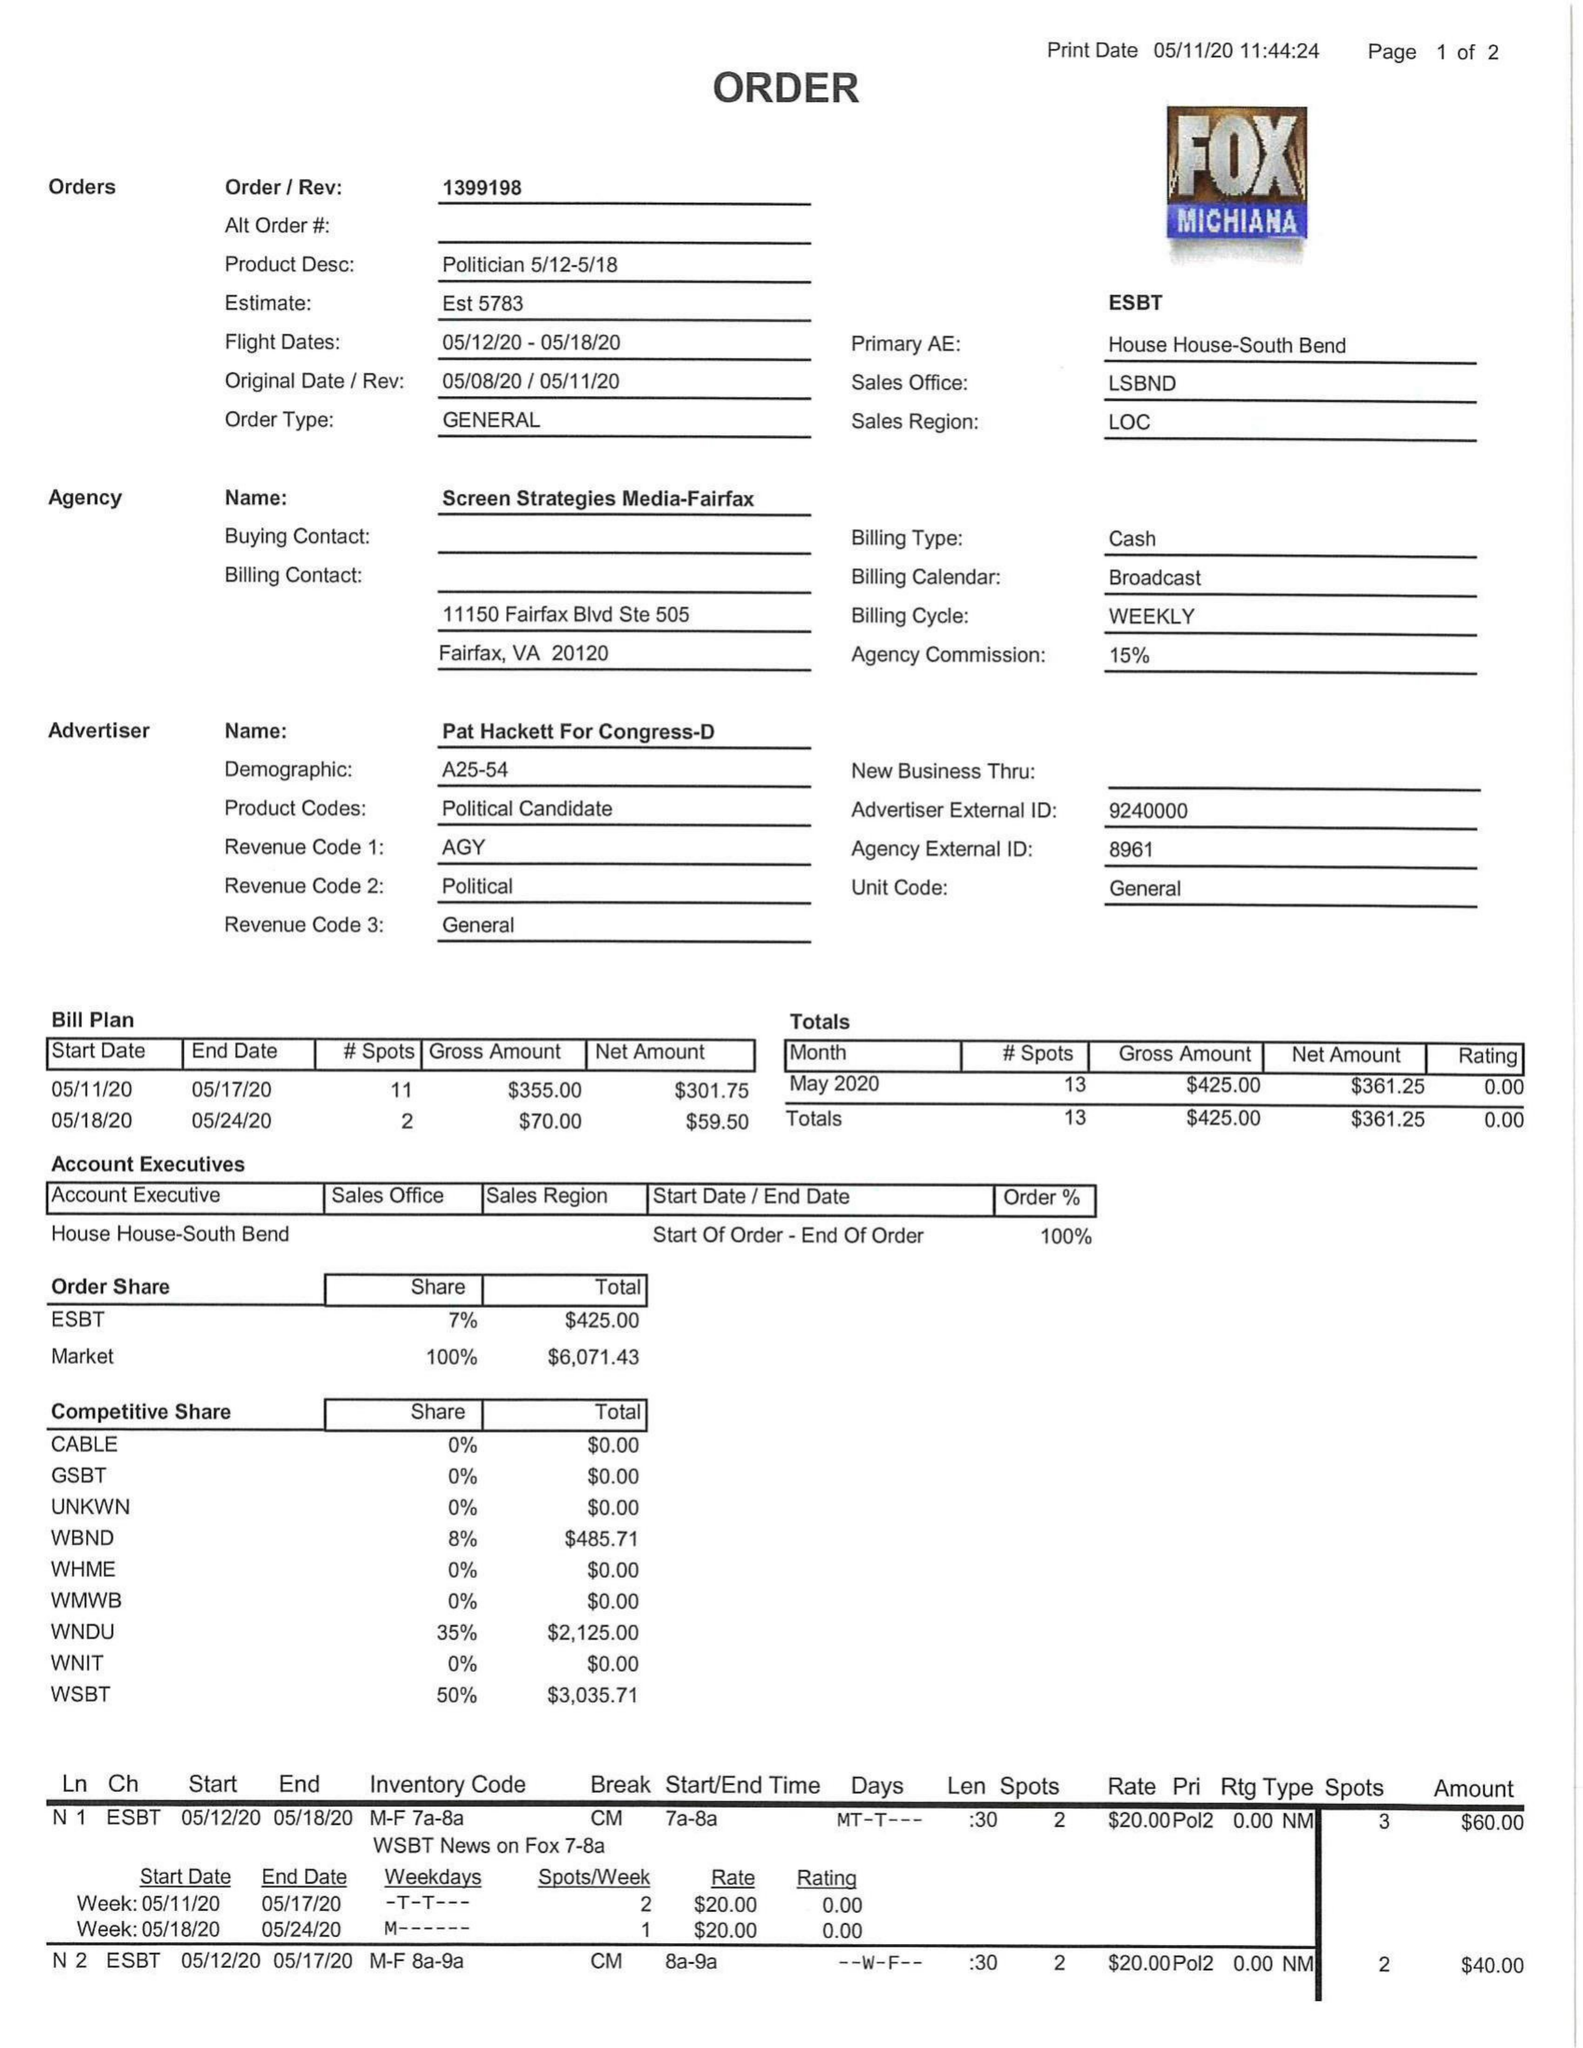What is the value for the advertiser?
Answer the question using a single word or phrase. PAT HACKETT FOR CONGRESS-D 